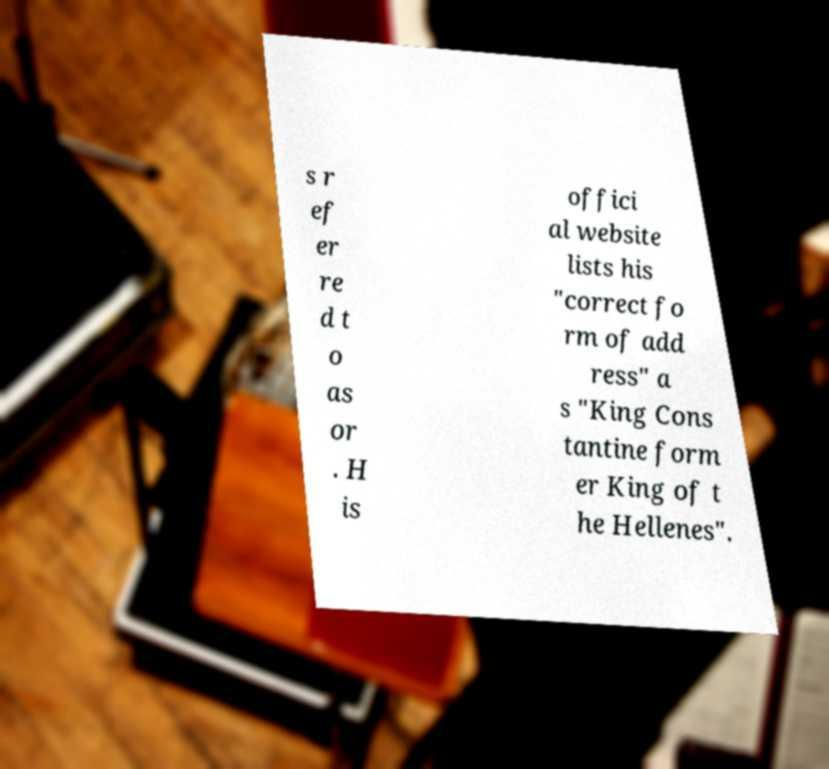I need the written content from this picture converted into text. Can you do that? s r ef er re d t o as or . H is offici al website lists his "correct fo rm of add ress" a s "King Cons tantine form er King of t he Hellenes". 